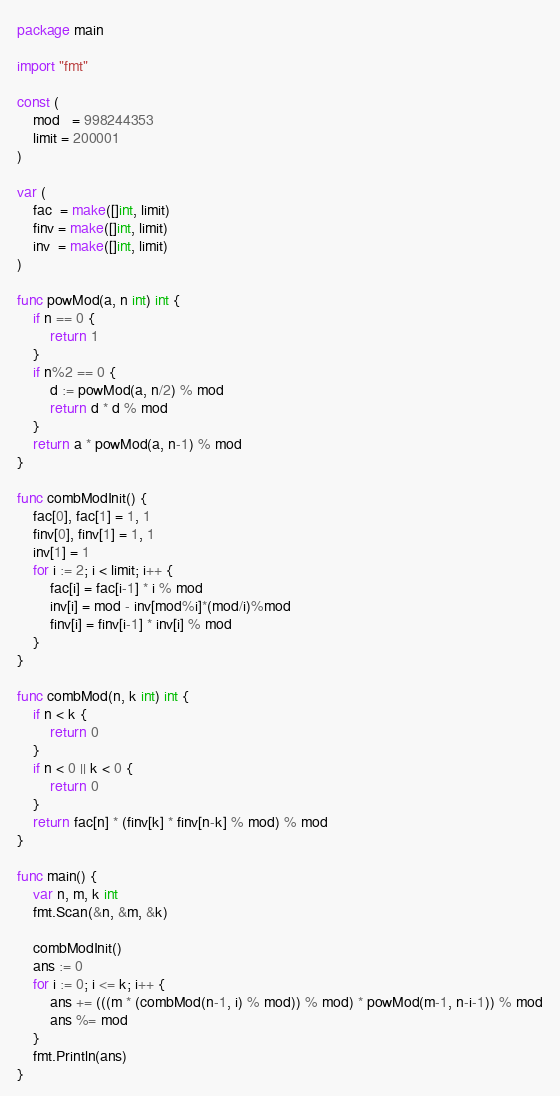Convert code to text. <code><loc_0><loc_0><loc_500><loc_500><_Go_>package main

import "fmt"

const (
	mod   = 998244353
	limit = 200001
)

var (
	fac  = make([]int, limit)
	finv = make([]int, limit)
	inv  = make([]int, limit)
)

func powMod(a, n int) int {
	if n == 0 {
		return 1
	}
	if n%2 == 0 {
		d := powMod(a, n/2) % mod
		return d * d % mod
	}
	return a * powMod(a, n-1) % mod
}

func combModInit() {
	fac[0], fac[1] = 1, 1
	finv[0], finv[1] = 1, 1
	inv[1] = 1
	for i := 2; i < limit; i++ {
		fac[i] = fac[i-1] * i % mod
		inv[i] = mod - inv[mod%i]*(mod/i)%mod
		finv[i] = finv[i-1] * inv[i] % mod
	}
}

func combMod(n, k int) int {
	if n < k {
		return 0
	}
	if n < 0 || k < 0 {
		return 0
	}
	return fac[n] * (finv[k] * finv[n-k] % mod) % mod
}

func main() {
	var n, m, k int
	fmt.Scan(&n, &m, &k)

	combModInit()
	ans := 0
	for i := 0; i <= k; i++ {
		ans += (((m * (combMod(n-1, i) % mod)) % mod) * powMod(m-1, n-i-1)) % mod
		ans %= mod
	}
	fmt.Println(ans)
}
</code> 